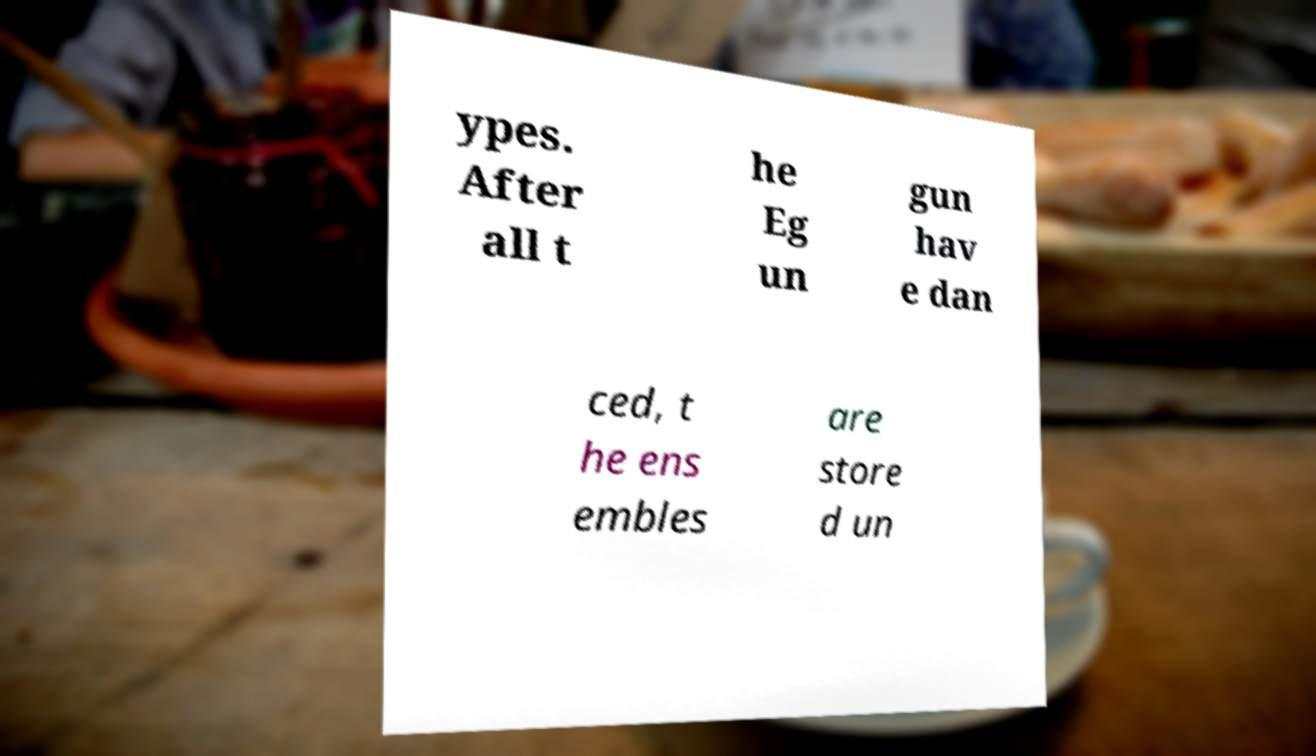Can you accurately transcribe the text from the provided image for me? ypes. After all t he Eg un gun hav e dan ced, t he ens embles are store d un 